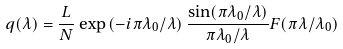<formula> <loc_0><loc_0><loc_500><loc_500>q ( \lambda ) = \frac { L } { N } \exp \left ( - i \pi \lambda _ { 0 } / \lambda \right ) \frac { \sin ( \pi \lambda _ { 0 } / \lambda ) } { \pi \lambda _ { 0 } / \lambda } F ( \pi \lambda / \lambda _ { 0 } )</formula> 